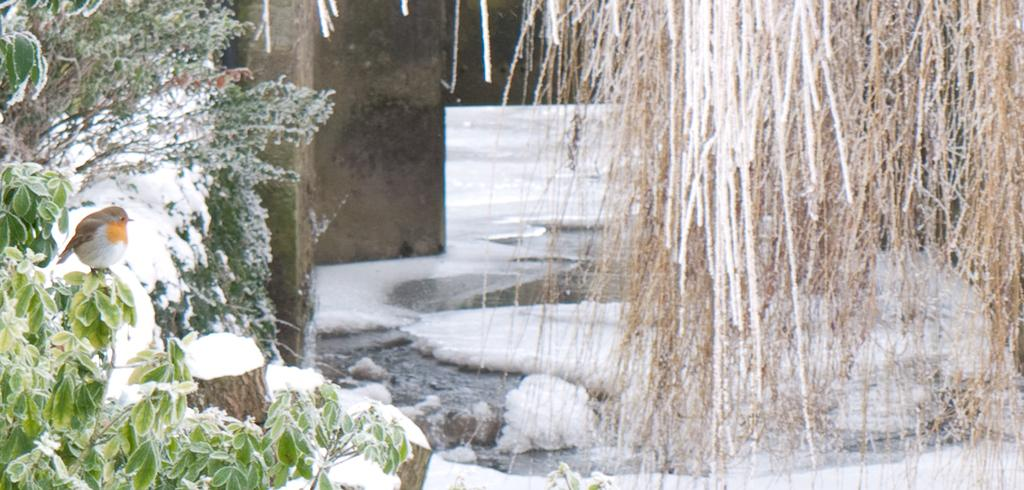What type of animals can be seen in the image? There are small birds in the image. Where are the birds located in the image? The birds are sitting on plants. What is the weather like in the image? There is snow visible in the image, indicating a cold environment. What type of vegetation is present in the image? Dry vines are present in the image. What can be seen in the background of the image? There is a wall in the background of the image. What grade did the army receive on their voyage in the image? There is no army, voyage, or grade present in the image. The image features small birds sitting on plants in a snowy environment with dry vines and a wall in the background. 